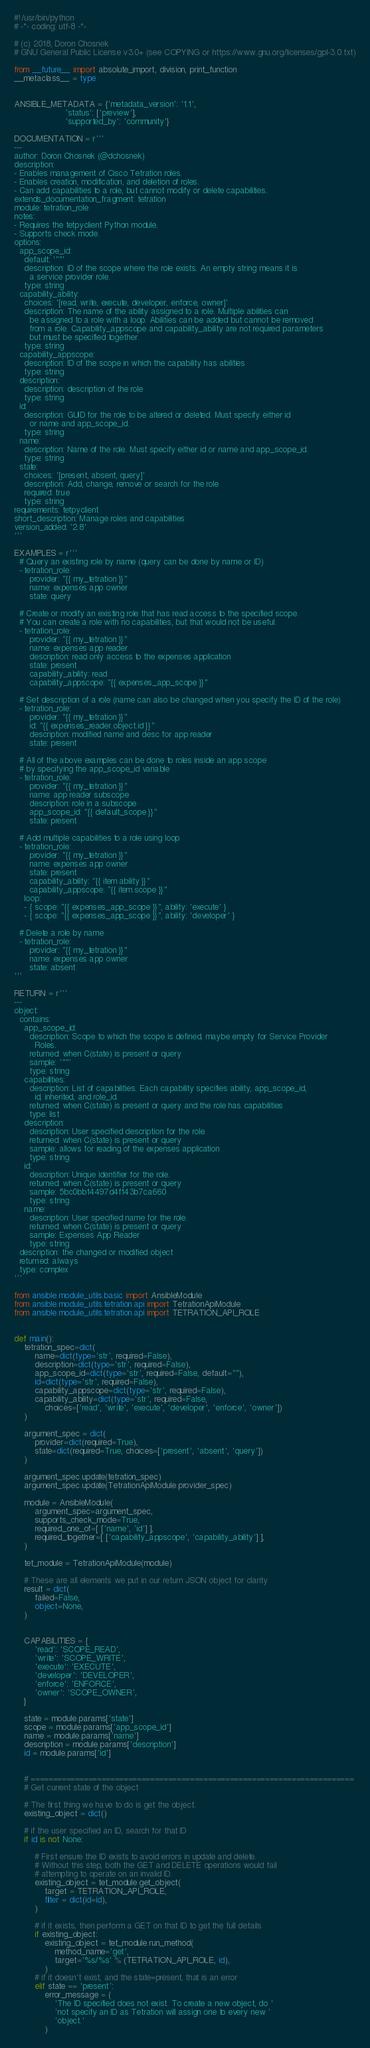Convert code to text. <code><loc_0><loc_0><loc_500><loc_500><_Python_>#!/usr/bin/python
# -*- coding: utf-8 -*-

# (c) 2018, Doron Chosnek
# GNU General Public License v3.0+ (see COPYING or https://www.gnu.org/licenses/gpl-3.0.txt)

from __future__ import absolute_import, division, print_function
__metaclass__ = type


ANSIBLE_METADATA = {'metadata_version': '1.1',
                    'status': ['preview'],
                    'supported_by': 'community'}

DOCUMENTATION = r'''
---
author: Doron Chosnek (@dchosnek)
description:
- Enables management of Cisco Tetration roles.
- Enables creation, modification, and deletion of roles.
- Can add capabilities to a role, but cannot modify or delete capabilities.
extends_documentation_fragment: tetration
module: tetration_role
notes:
- Requires the tetpyclient Python module.
- Supports check mode.
options:
  app_scope_id:
    default: '""'
    description: ID of the scope where the role exists. An empty string means it is
      a service provider role.
    type: string
  capability_ability:
    choices: '[read, write, execute, developer, enforce, owner]'
    description: The name of the ability assigned to a role. Multiple abilities can
      be assigned to a role with a loop. Abilities can be added but cannot be removed
      from a role. Capability_appscope and capability_ability are not required parameters
      but must be specified together.
    type: string
  capability_appscope:
    description: ID of the scope in which the capability has abilities
    type: string
  description:
    description: description of the role
    type: string
  id:
    description: GUID for the role to be altered or deleted. Must specify either id
      or name and app_scope_id.
    type: string
  name:
    description: Name of the role. Must specify either id or name and app_scope_id.
    type: string
  state:
    choices: '[present, absent, query]'
    description: Add, change, remove or search for the role
    required: true
    type: string
requirements: tetpyclient
short_description: Manage roles and capabilities
version_added: '2.8'
'''

EXAMPLES = r'''
  # Query an existing role by name (query can be done by name or ID)
  - tetration_role:
      provider: "{{ my_tetration }}"
      name: expenses app owner
      state: query

  # Create or modify an existing role that has read access to the specified scope.
  # You can create a role with no capabilities, but that would not be useful.
  - tetration_role:
      provider: "{{ my_tetration }}"
      name: expenses app reader
      description: read only access to the expenses application
      state: present
      capability_ability: read
      capability_appscope: "{{ expenses_app_scope }}"

  # Set description of a role (name can also be changed when you specify the ID of the role) 
  - tetration_role:
      provider: "{{ my_tetration }}"
      id: "{{ expenses_reader.object.id }}"
      description: modified name and desc for app reader
      state: present

  # All of the above examples can be done to roles inside an app scope 
  # by specifying the app_scope_id variable
  - tetration_role:
      provider: "{{ my_tetration }}"
      name: app reader subscope
      description: role in a subscope
      app_scope_id: "{{ default_scope }}"
      state: present

  # Add multiple capabilities to a role using loop
  - tetration_role:
      provider: "{{ my_tetration }}"
      name: expenses app owner
      state: present
      capability_ability: "{{ item.ability }}"
      capability_appscope: "{{ item.scope }}"
    loop:
    - { scope: "{{ expenses_app_scope }}", ability: 'execute' }
    - { scope: "{{ expenses_app_scope }}", ability: 'developer' }

  # Delete a role by name
  - tetration_role:
      provider: "{{ my_tetration }}"
      name: expenses app owner
      state: absent
'''

RETURN = r'''
---
object:
  contains:
    app_scope_id:
      description: Scope to which the scope is defined, maybe empty for Service Provider
        Roles.
      returned: when C(state) is present or query
      sample: '""'
      type: string
    capabilities:
      description: List of capabilities. Each capability specifies ability, app_scope_id,
        id, inherited, and role_id.
      returned: when C(state) is present or query and the role has capabilities
      type: list
    description:
      description: User specified description for the role.
      returned: when C(state) is present or query
      sample: allows for reading of the expenses application
      type: string
    id:
      description: Unique identifier for the role.
      returned: when C(state) is present or query
      sample: 5bc0bb14497d4f143b7ca660
      type: string
    name:
      description: User specified name for the role.
      returned: when C(state) is present or query
      sample: Expenses App Reader
      type: string
  description: the changed or modified object
  returned: always
  type: complex
'''

from ansible.module_utils.basic import AnsibleModule
from ansible.module_utils.tetration.api import TetrationApiModule
from ansible.module_utils.tetration.api import TETRATION_API_ROLE


def main():
    tetration_spec=dict(
        name=dict(type='str', required=False),
        description=dict(type='str', required=False),
        app_scope_id=dict(type='str', required=False, default=""),
        id=dict(type='str', required=False),
        capability_appscope=dict(type='str', required=False),
        capability_ability=dict(type='str', required=False, 
            choices=['read', 'write', 'execute', 'developer', 'enforce', 'owner'])
    )

    argument_spec = dict(
        provider=dict(required=True),
        state=dict(required=True, choices=['present', 'absent', 'query'])
    )

    argument_spec.update(tetration_spec)
    argument_spec.update(TetrationApiModule.provider_spec)

    module = AnsibleModule(
        argument_spec=argument_spec,
        supports_check_mode=True,
        required_one_of=[ ['name', 'id'] ],
        required_together=[ ['capability_appscope', 'capability_ability'] ],
    )

    tet_module = TetrationApiModule(module)

    # These are all elements we put in our return JSON object for clarity
    result = dict(
        failed=False,
        object=None,
    )


    CAPABILITIES = {
        'read': 'SCOPE_READ',
        'write': 'SCOPE_WRITE',
        'execute': 'EXECUTE',
        'developer': 'DEVELOPER',
        'enforce': 'ENFORCE',
        'owner': 'SCOPE_OWNER',
    }

    state = module.params['state']
    scope = module.params['app_scope_id']
    name = module.params['name']
    description = module.params['description']
    id = module.params['id']


    # =========================================================================
    # Get current state of the object

    # The first thing we have to do is get the object.
    existing_object = dict()
    
    # if the user specified an ID, search for that ID
    if id is not None:

        # First ensure the ID exists to avoid errors in update and delete.
        # Without this step, both the GET and DELETE operations would fail
        # attempting to operate on an invalid ID.
        existing_object = tet_module.get_object(
            target = TETRATION_API_ROLE,
            filter = dict(id=id),
        )

        # if it exists, then perform a GET on that ID to get the full details
        if existing_object:
            existing_object = tet_module.run_method(
                method_name='get',
                target='%s/%s' % (TETRATION_API_ROLE, id),
            )
        # if it doesn't exist, and the state=present, that is an error
        elif state == 'present':
            error_message = (
                'The ID specified does not exist. To create a new object, do '
                'not specify an ID as Tetration will assign one to every new '
                'object.'
            )</code> 